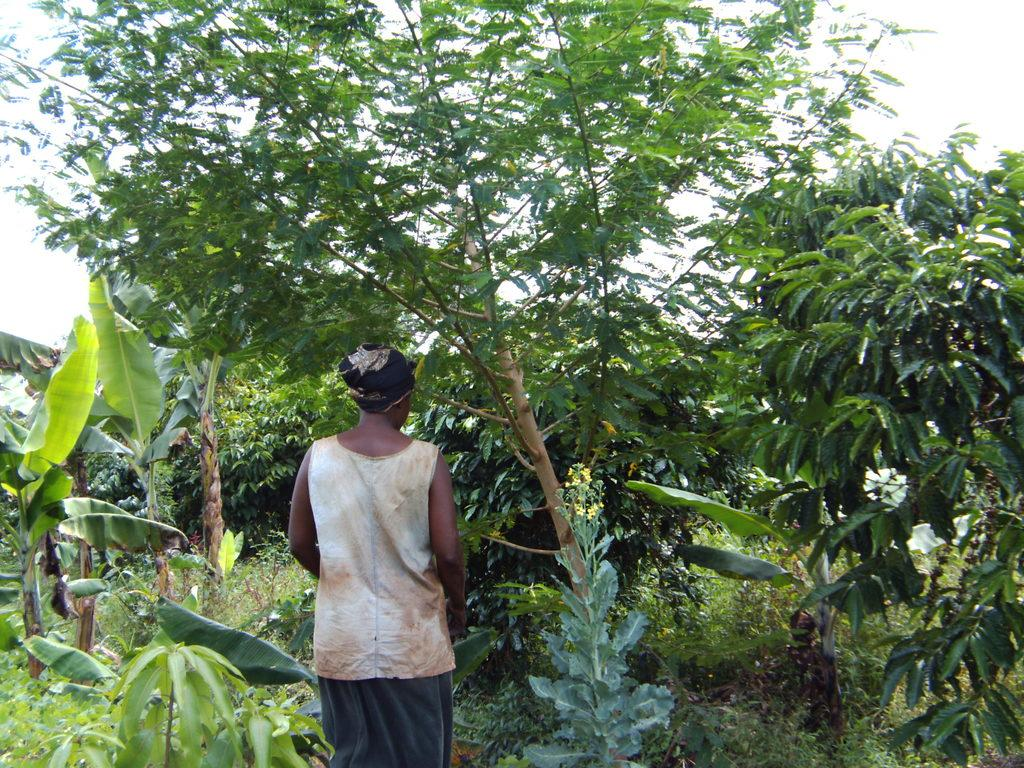Who or what is present in the image? There is a person in the image. What can be seen in the background of the image? There are trees and plants in the background of the image. What is visible at the top of the image? The sky is visible at the top of the image. How many yams are being held by the person in the image? There are no yams present in the image. What type of net is being used by the person in the image? There is no net present in the image. 